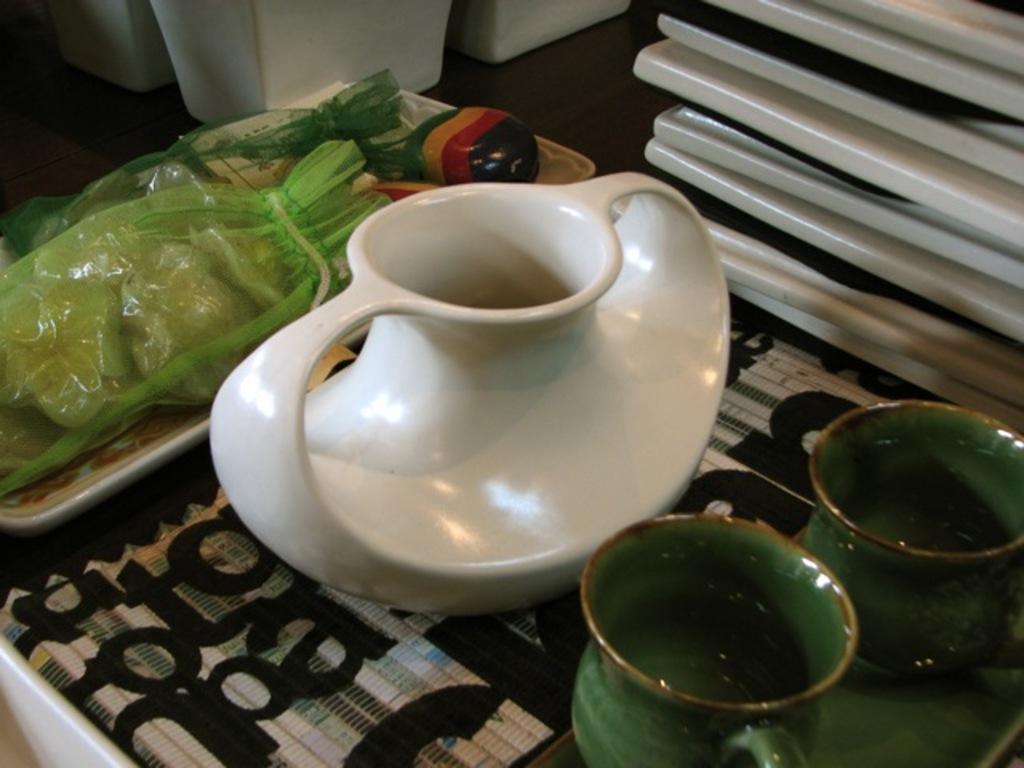How would you summarize this image in a sentence or two? In this image we can see two cups ,a jug and a tray with bags are placed on the surface. 